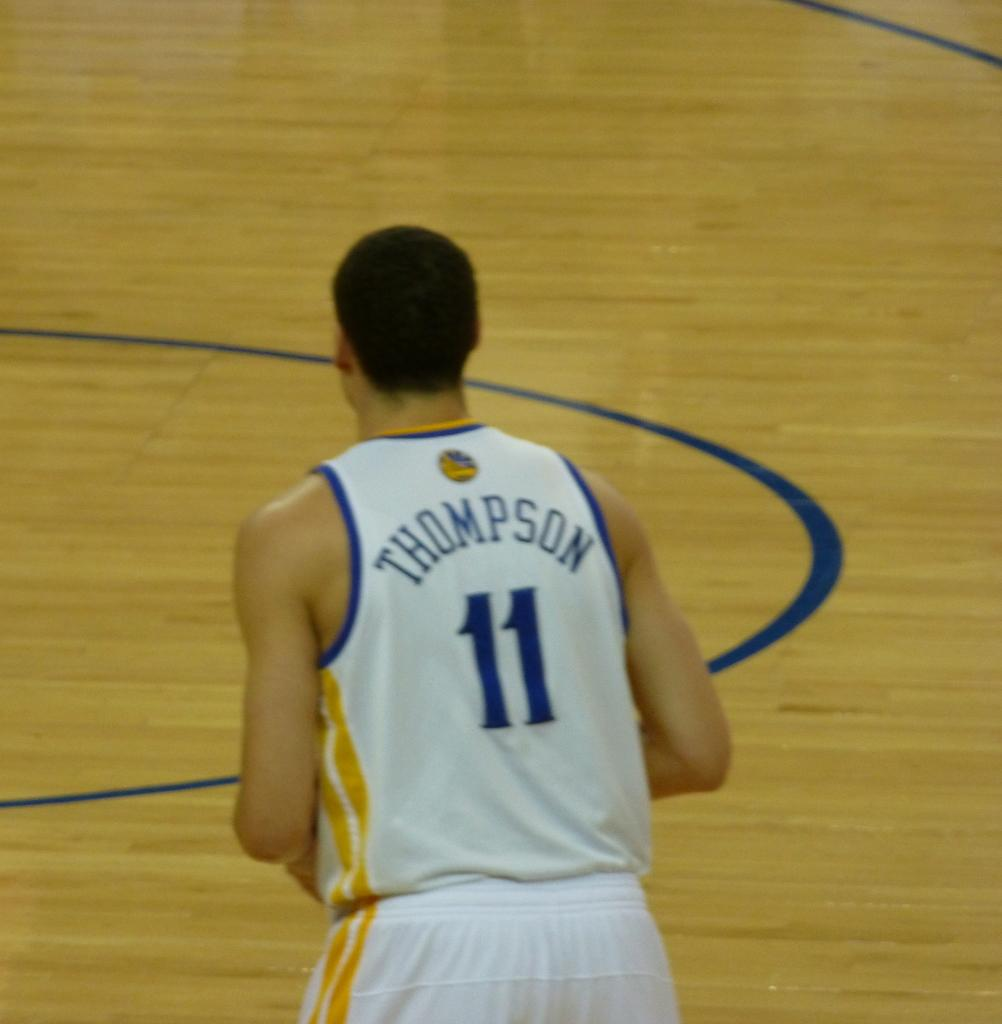<image>
Provide a brief description of the given image. A player on a basketball court wears a shirt that says, "Thompson 11". 